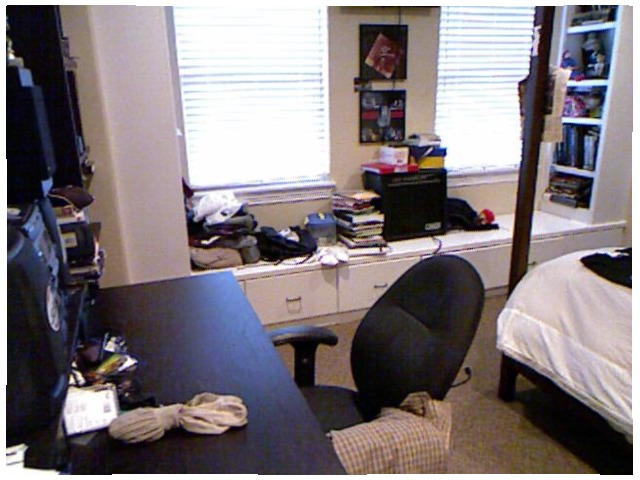<image>
Can you confirm if the shirt is on the chair? Yes. Looking at the image, I can see the shirt is positioned on top of the chair, with the chair providing support. Where is the blinds in relation to the chair? Is it next to the chair? Yes. The blinds is positioned adjacent to the chair, located nearby in the same general area. Where is the desk in relation to the socks? Is it next to the socks? No. The desk is not positioned next to the socks. They are located in different areas of the scene. 